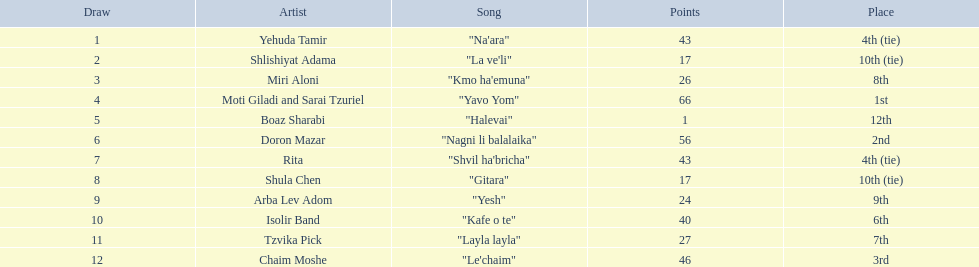What are the point values in the competition? 43, 17, 26, 66, 1, 56, 43, 17, 24, 40, 27, 46. What is the lowest point value? 1. Who is the artist that got these points? Boaz Sharabi. 